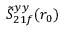<formula> <loc_0><loc_0><loc_500><loc_500>\tilde { S } _ { 2 1 f } ^ { y y } ( r _ { 0 } )</formula> 